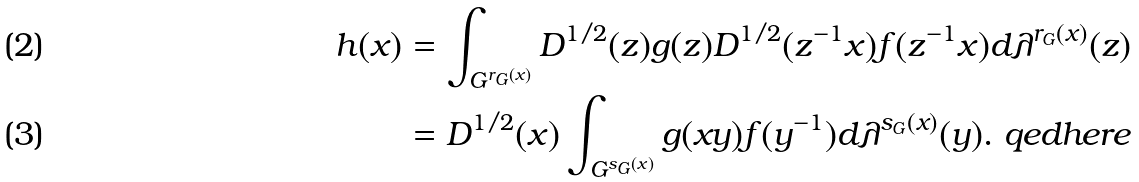Convert formula to latex. <formula><loc_0><loc_0><loc_500><loc_500>h ( x ) & = \int _ { G ^ { r _ { G } ( x ) } } D ^ { 1 / 2 } ( z ) g ( z ) D ^ { 1 / 2 } ( z ^ { - 1 } x ) f ( z ^ { - 1 } x ) d \lambda ^ { r _ { G } ( x ) } ( z ) \\ & = D ^ { 1 / 2 } ( x ) \int _ { G ^ { s _ { G } ( x ) } } g ( x y ) f ( y ^ { - 1 } ) d \lambda ^ { s _ { G } ( x ) } ( y ) . \ q e d h e r e</formula> 